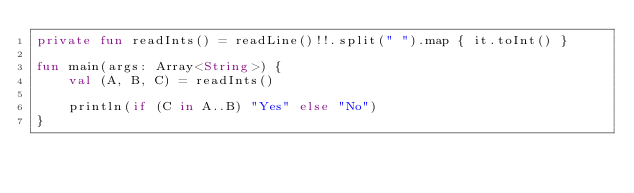<code> <loc_0><loc_0><loc_500><loc_500><_Kotlin_>private fun readInts() = readLine()!!.split(" ").map { it.toInt() }

fun main(args: Array<String>) {
    val (A, B, C) = readInts()

    println(if (C in A..B) "Yes" else "No")
}</code> 